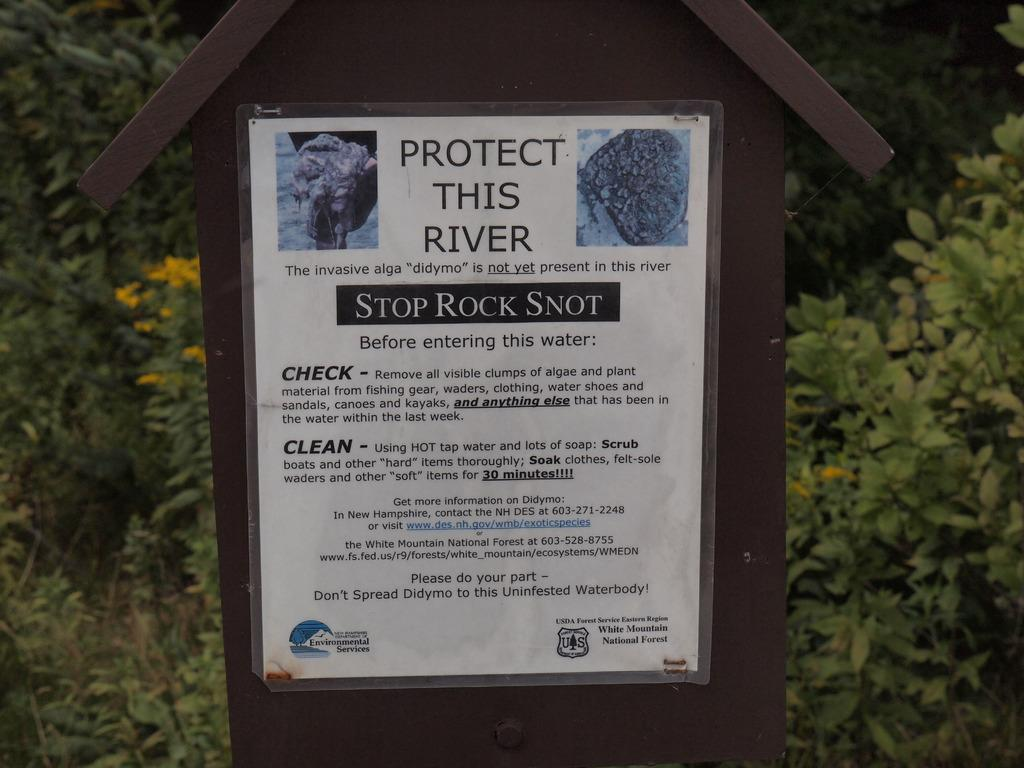What is on the board in the image? There is a poster on the board in the image. What can be found on the poster? The poster contains text and images. What can be seen in the background of the image? There are trees visible in the background of the image. Is there a fireman putting out a fire in the image? No, there is no fireman or fire present in the image. Is the scene taking place during winter in the image? The image does not provide any information about the season or weather, so it cannot be determined if it is winter. 